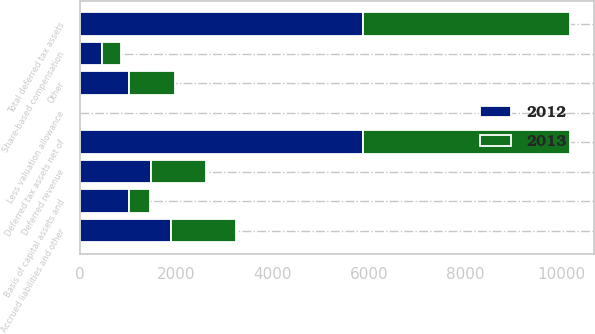Convert chart. <chart><loc_0><loc_0><loc_500><loc_500><stacked_bar_chart><ecel><fcel>Accrued liabilities and other<fcel>Deferred revenue<fcel>Basis of capital assets and<fcel>Share-based compensation<fcel>Other<fcel>Total deferred tax assets<fcel>Less valuation allowance<fcel>Deferred tax assets net of<nl><fcel>2012<fcel>1892<fcel>1475<fcel>1020<fcel>458<fcel>1029<fcel>5874<fcel>0<fcel>5874<nl><fcel>2013<fcel>1346<fcel>1145<fcel>451<fcel>411<fcel>947<fcel>4300<fcel>0<fcel>4300<nl></chart> 